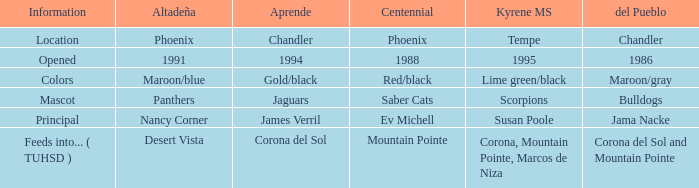What kind of Altadeña has del Pueblo of maroon/gray? Maroon/blue. 